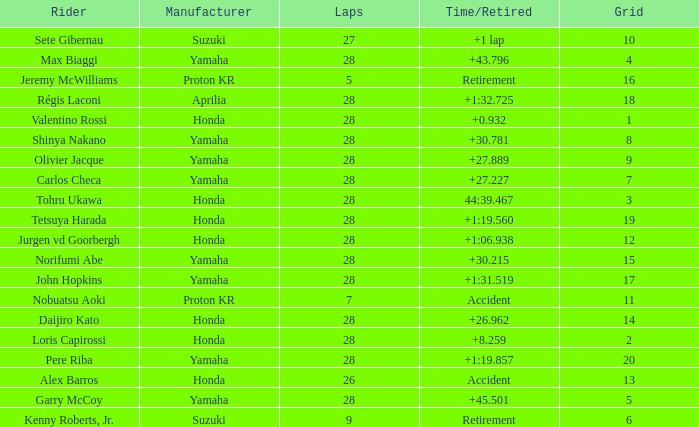How many laps were in grid 4? 28.0. I'm looking to parse the entire table for insights. Could you assist me with that? {'header': ['Rider', 'Manufacturer', 'Laps', 'Time/Retired', 'Grid'], 'rows': [['Sete Gibernau', 'Suzuki', '27', '+1 lap', '10'], ['Max Biaggi', 'Yamaha', '28', '+43.796', '4'], ['Jeremy McWilliams', 'Proton KR', '5', 'Retirement', '16'], ['Régis Laconi', 'Aprilia', '28', '+1:32.725', '18'], ['Valentino Rossi', 'Honda', '28', '+0.932', '1'], ['Shinya Nakano', 'Yamaha', '28', '+30.781', '8'], ['Olivier Jacque', 'Yamaha', '28', '+27.889', '9'], ['Carlos Checa', 'Yamaha', '28', '+27.227', '7'], ['Tohru Ukawa', 'Honda', '28', '44:39.467', '3'], ['Tetsuya Harada', 'Honda', '28', '+1:19.560', '19'], ['Jurgen vd Goorbergh', 'Honda', '28', '+1:06.938', '12'], ['Norifumi Abe', 'Yamaha', '28', '+30.215', '15'], ['John Hopkins', 'Yamaha', '28', '+1:31.519', '17'], ['Nobuatsu Aoki', 'Proton KR', '7', 'Accident', '11'], ['Daijiro Kato', 'Honda', '28', '+26.962', '14'], ['Loris Capirossi', 'Honda', '28', '+8.259', '2'], ['Pere Riba', 'Yamaha', '28', '+1:19.857', '20'], ['Alex Barros', 'Honda', '26', 'Accident', '13'], ['Garry McCoy', 'Yamaha', '28', '+45.501', '5'], ['Kenny Roberts, Jr.', 'Suzuki', '9', 'Retirement', '6']]} 